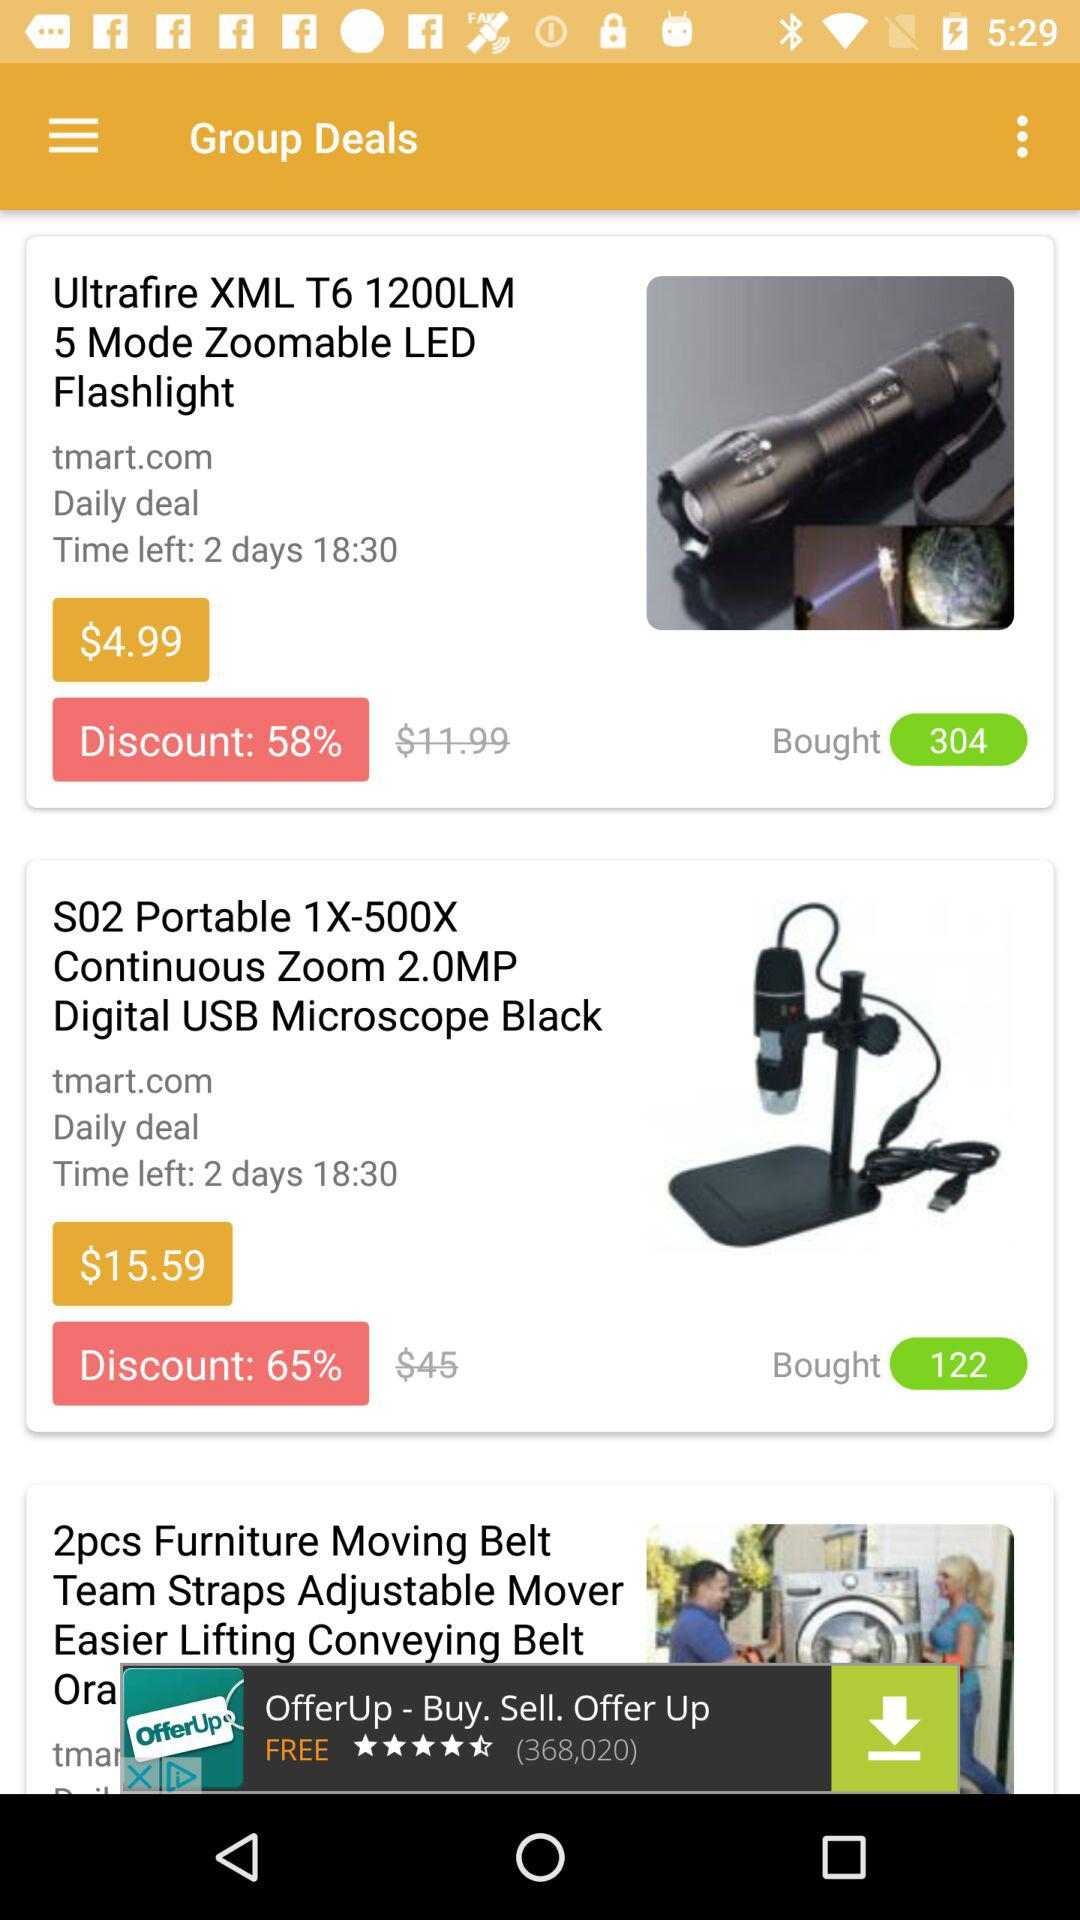What is the discounted price of the "Ultrafire XML T6 1200LM"? The discounted price of the "Ultrafire XML T6 1200LM" is $4.99. 